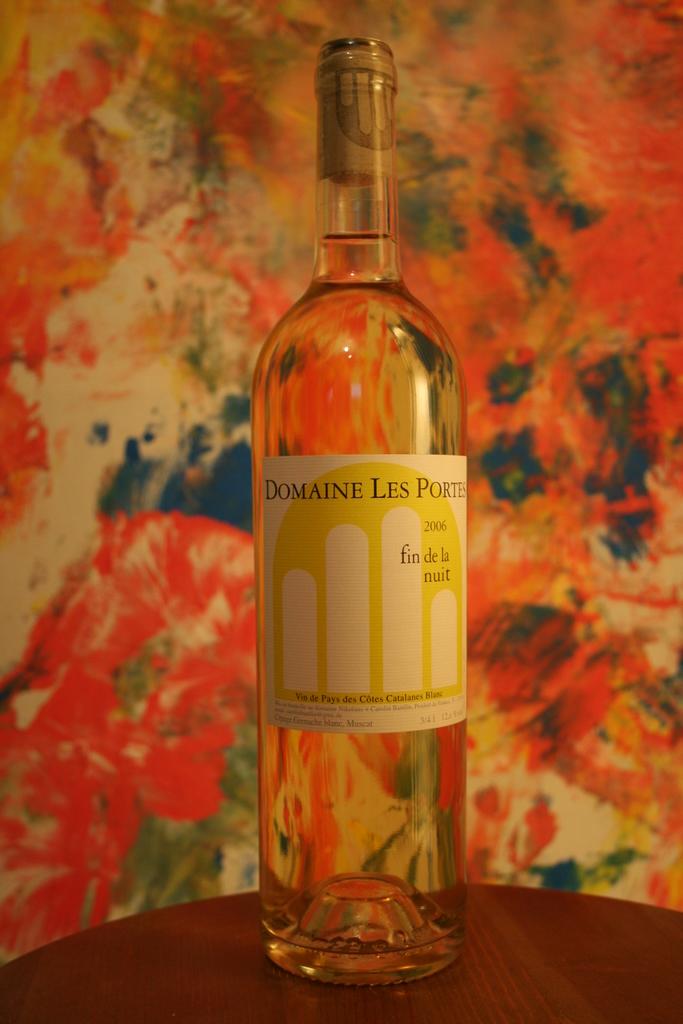What brand of wine is this?
Provide a succinct answer. Domaine les portes. What type of wine is this?
Ensure brevity in your answer.  Domaine les portes. 